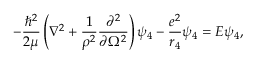Convert formula to latex. <formula><loc_0><loc_0><loc_500><loc_500>- \frac { \hbar { ^ } { 2 } } { 2 \mu } \left ( \nabla ^ { 2 } + \frac { 1 } { \rho ^ { 2 } } \frac { \partial ^ { 2 } } { \partial \Omega ^ { 2 } } \right ) \psi _ { 4 } - \frac { e ^ { 2 } } { r _ { 4 } } \psi _ { 4 } = E \psi _ { 4 } ,</formula> 